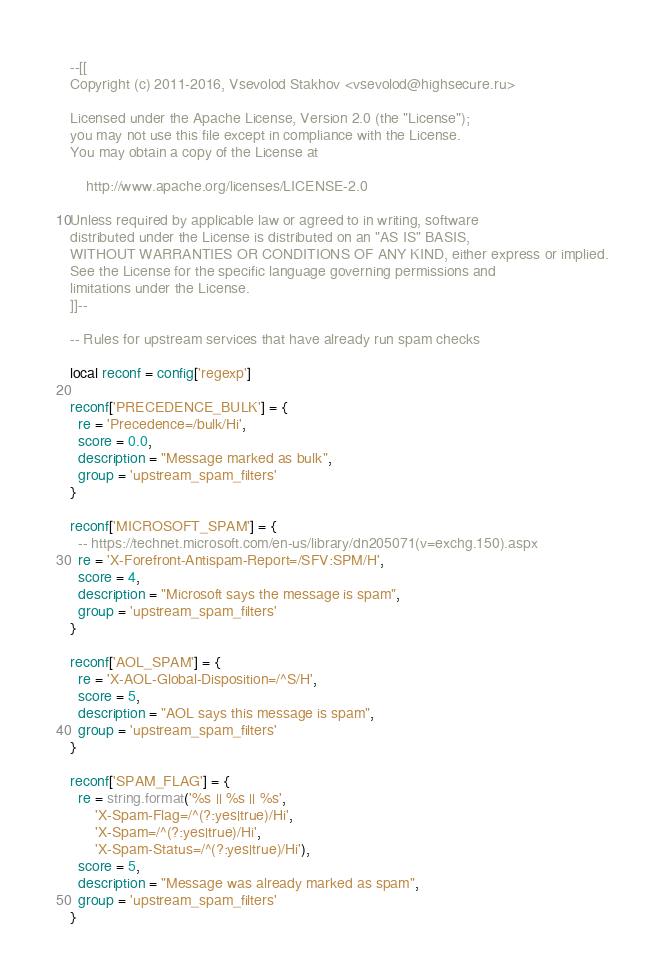<code> <loc_0><loc_0><loc_500><loc_500><_Lua_>--[[
Copyright (c) 2011-2016, Vsevolod Stakhov <vsevolod@highsecure.ru>

Licensed under the Apache License, Version 2.0 (the "License");
you may not use this file except in compliance with the License.
You may obtain a copy of the License at

    http://www.apache.org/licenses/LICENSE-2.0

Unless required by applicable law or agreed to in writing, software
distributed under the License is distributed on an "AS IS" BASIS,
WITHOUT WARRANTIES OR CONDITIONS OF ANY KIND, either express or implied.
See the License for the specific language governing permissions and
limitations under the License.
]]--

-- Rules for upstream services that have already run spam checks

local reconf = config['regexp']

reconf['PRECEDENCE_BULK'] = {
  re = 'Precedence=/bulk/Hi',
  score = 0.0,
  description = "Message marked as bulk",
  group = 'upstream_spam_filters'
}

reconf['MICROSOFT_SPAM'] = {
  -- https://technet.microsoft.com/en-us/library/dn205071(v=exchg.150).aspx
  re = 'X-Forefront-Antispam-Report=/SFV:SPM/H',
  score = 4,
  description = "Microsoft says the message is spam",
  group = 'upstream_spam_filters'
}

reconf['AOL_SPAM'] = {
  re = 'X-AOL-Global-Disposition=/^S/H',
  score = 5,
  description = "AOL says this message is spam",
  group = 'upstream_spam_filters'
}

reconf['SPAM_FLAG'] = {
  re = string.format('%s || %s || %s',
      'X-Spam-Flag=/^(?:yes|true)/Hi',
      'X-Spam=/^(?:yes|true)/Hi',
      'X-Spam-Status=/^(?:yes|true)/Hi'),
  score = 5,
  description = "Message was already marked as spam",
  group = 'upstream_spam_filters'
}
</code> 